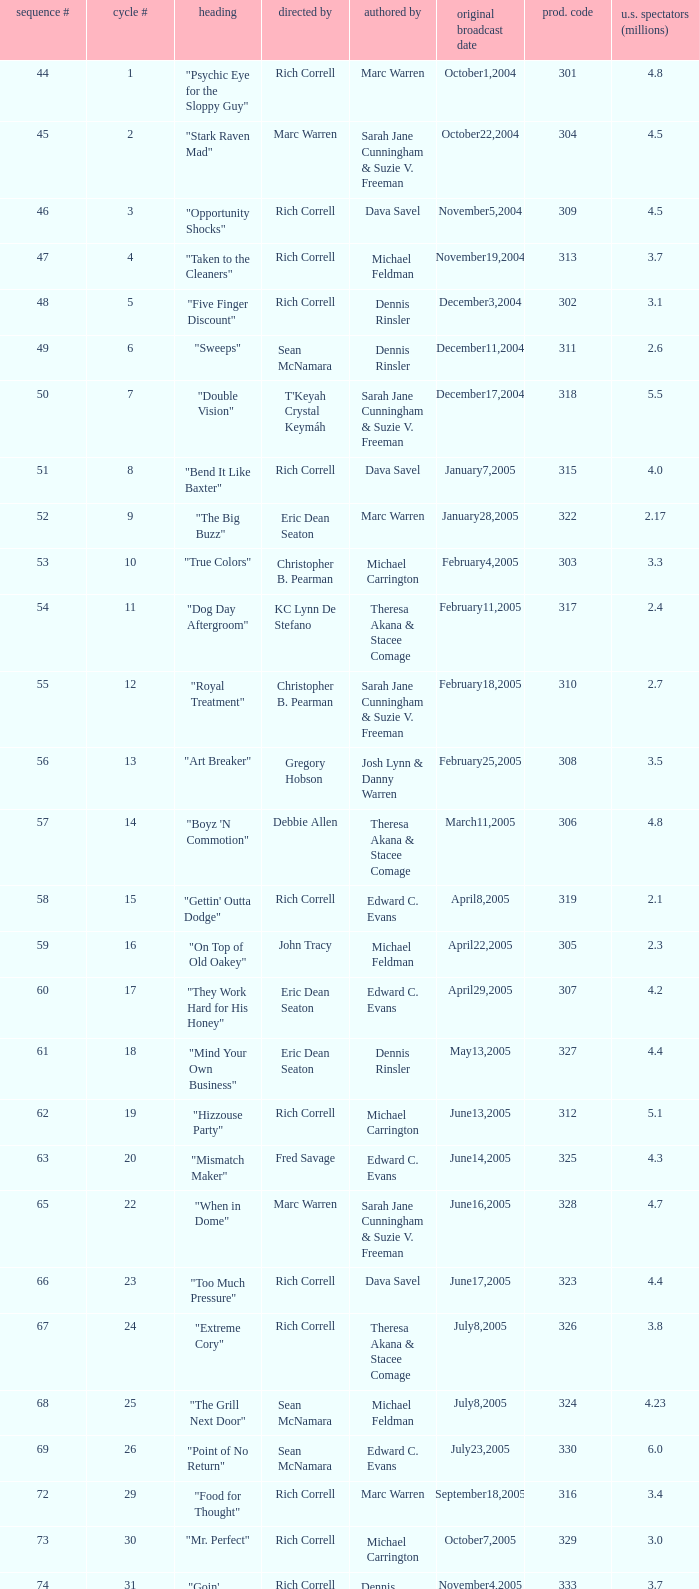What number episode of the season was titled "Vision Impossible"? 34.0. 